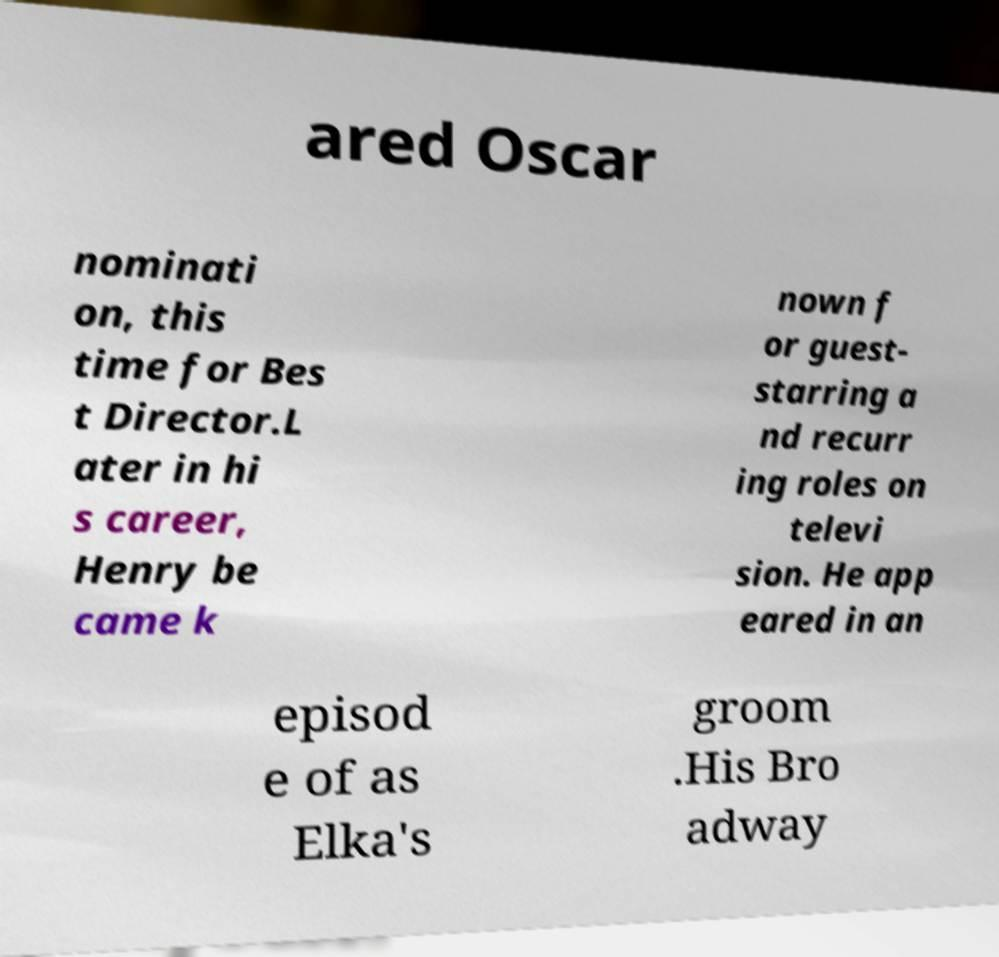I need the written content from this picture converted into text. Can you do that? ared Oscar nominati on, this time for Bes t Director.L ater in hi s career, Henry be came k nown f or guest- starring a nd recurr ing roles on televi sion. He app eared in an episod e of as Elka's groom .His Bro adway 